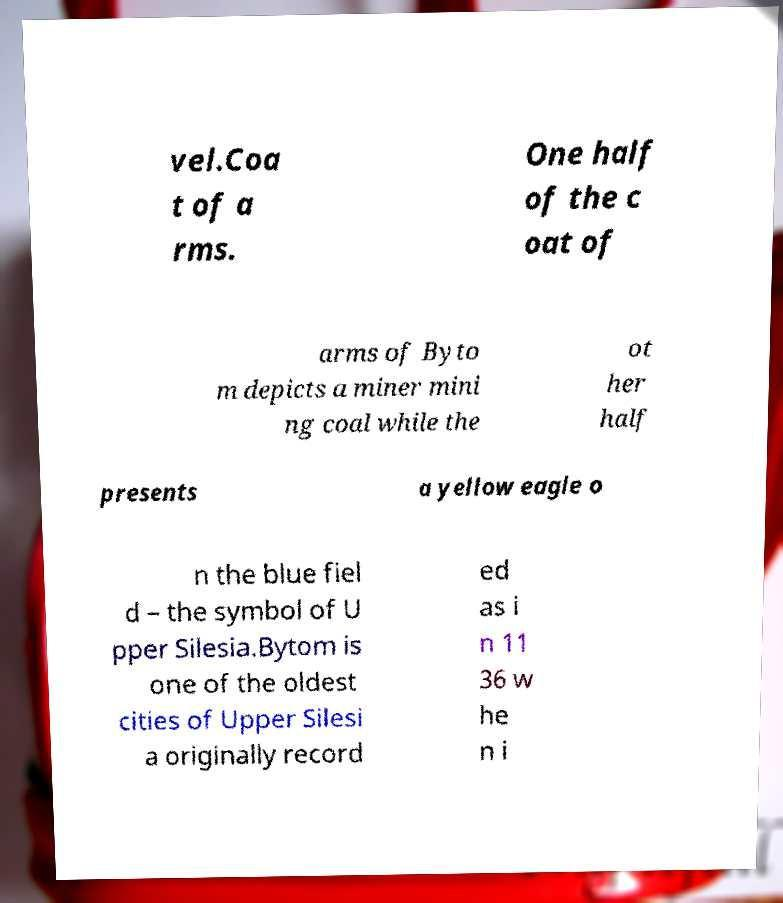Please read and relay the text visible in this image. What does it say? vel.Coa t of a rms. One half of the c oat of arms of Byto m depicts a miner mini ng coal while the ot her half presents a yellow eagle o n the blue fiel d – the symbol of U pper Silesia.Bytom is one of the oldest cities of Upper Silesi a originally record ed as i n 11 36 w he n i 